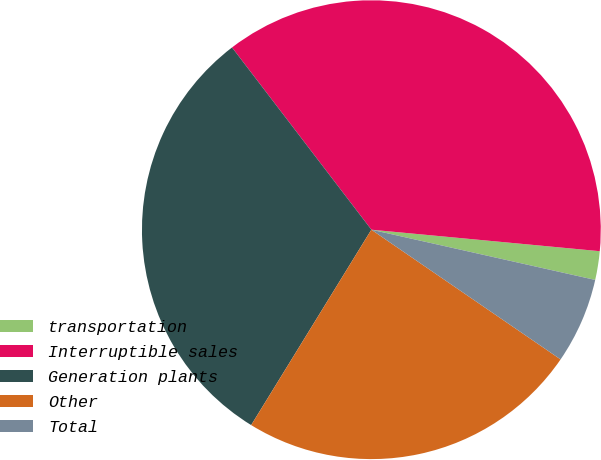<chart> <loc_0><loc_0><loc_500><loc_500><pie_chart><fcel>transportation<fcel>Interruptible sales<fcel>Generation plants<fcel>Other<fcel>Total<nl><fcel>2.02%<fcel>36.88%<fcel>30.83%<fcel>24.21%<fcel>6.05%<nl></chart> 